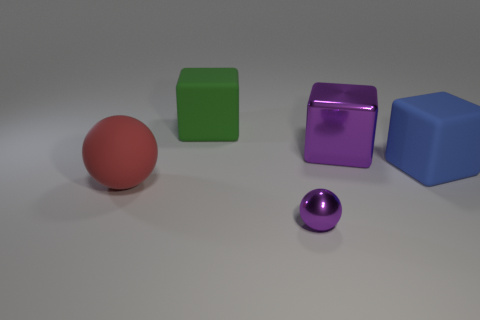Is the number of big matte cubes that are on the right side of the big metal thing the same as the number of purple balls?
Your answer should be very brief. Yes. What size is the thing that is both in front of the blue rubber object and behind the small purple metal thing?
Offer a very short reply. Large. Is there anything else that has the same color as the rubber sphere?
Offer a very short reply. No. How big is the purple metal thing behind the block that is right of the purple block?
Your answer should be compact. Large. What color is the matte thing that is both in front of the green block and behind the red thing?
Provide a succinct answer. Blue. What number of other things are there of the same size as the red object?
Give a very brief answer. 3. There is a rubber ball; is it the same size as the cube on the left side of the metallic sphere?
Provide a succinct answer. Yes. What is the color of the shiny cube that is the same size as the red matte ball?
Offer a very short reply. Purple. How big is the red thing?
Ensure brevity in your answer.  Large. Are the sphere that is to the right of the large sphere and the large green thing made of the same material?
Ensure brevity in your answer.  No. 